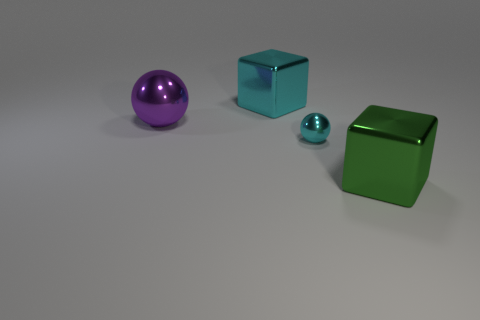Add 1 large purple things. How many objects exist? 5 Subtract 2 spheres. How many spheres are left? 0 Subtract all big cyan objects. Subtract all small balls. How many objects are left? 2 Add 2 tiny metal spheres. How many tiny metal spheres are left? 3 Add 2 objects. How many objects exist? 6 Subtract 0 gray spheres. How many objects are left? 4 Subtract all green spheres. Subtract all purple cylinders. How many spheres are left? 2 